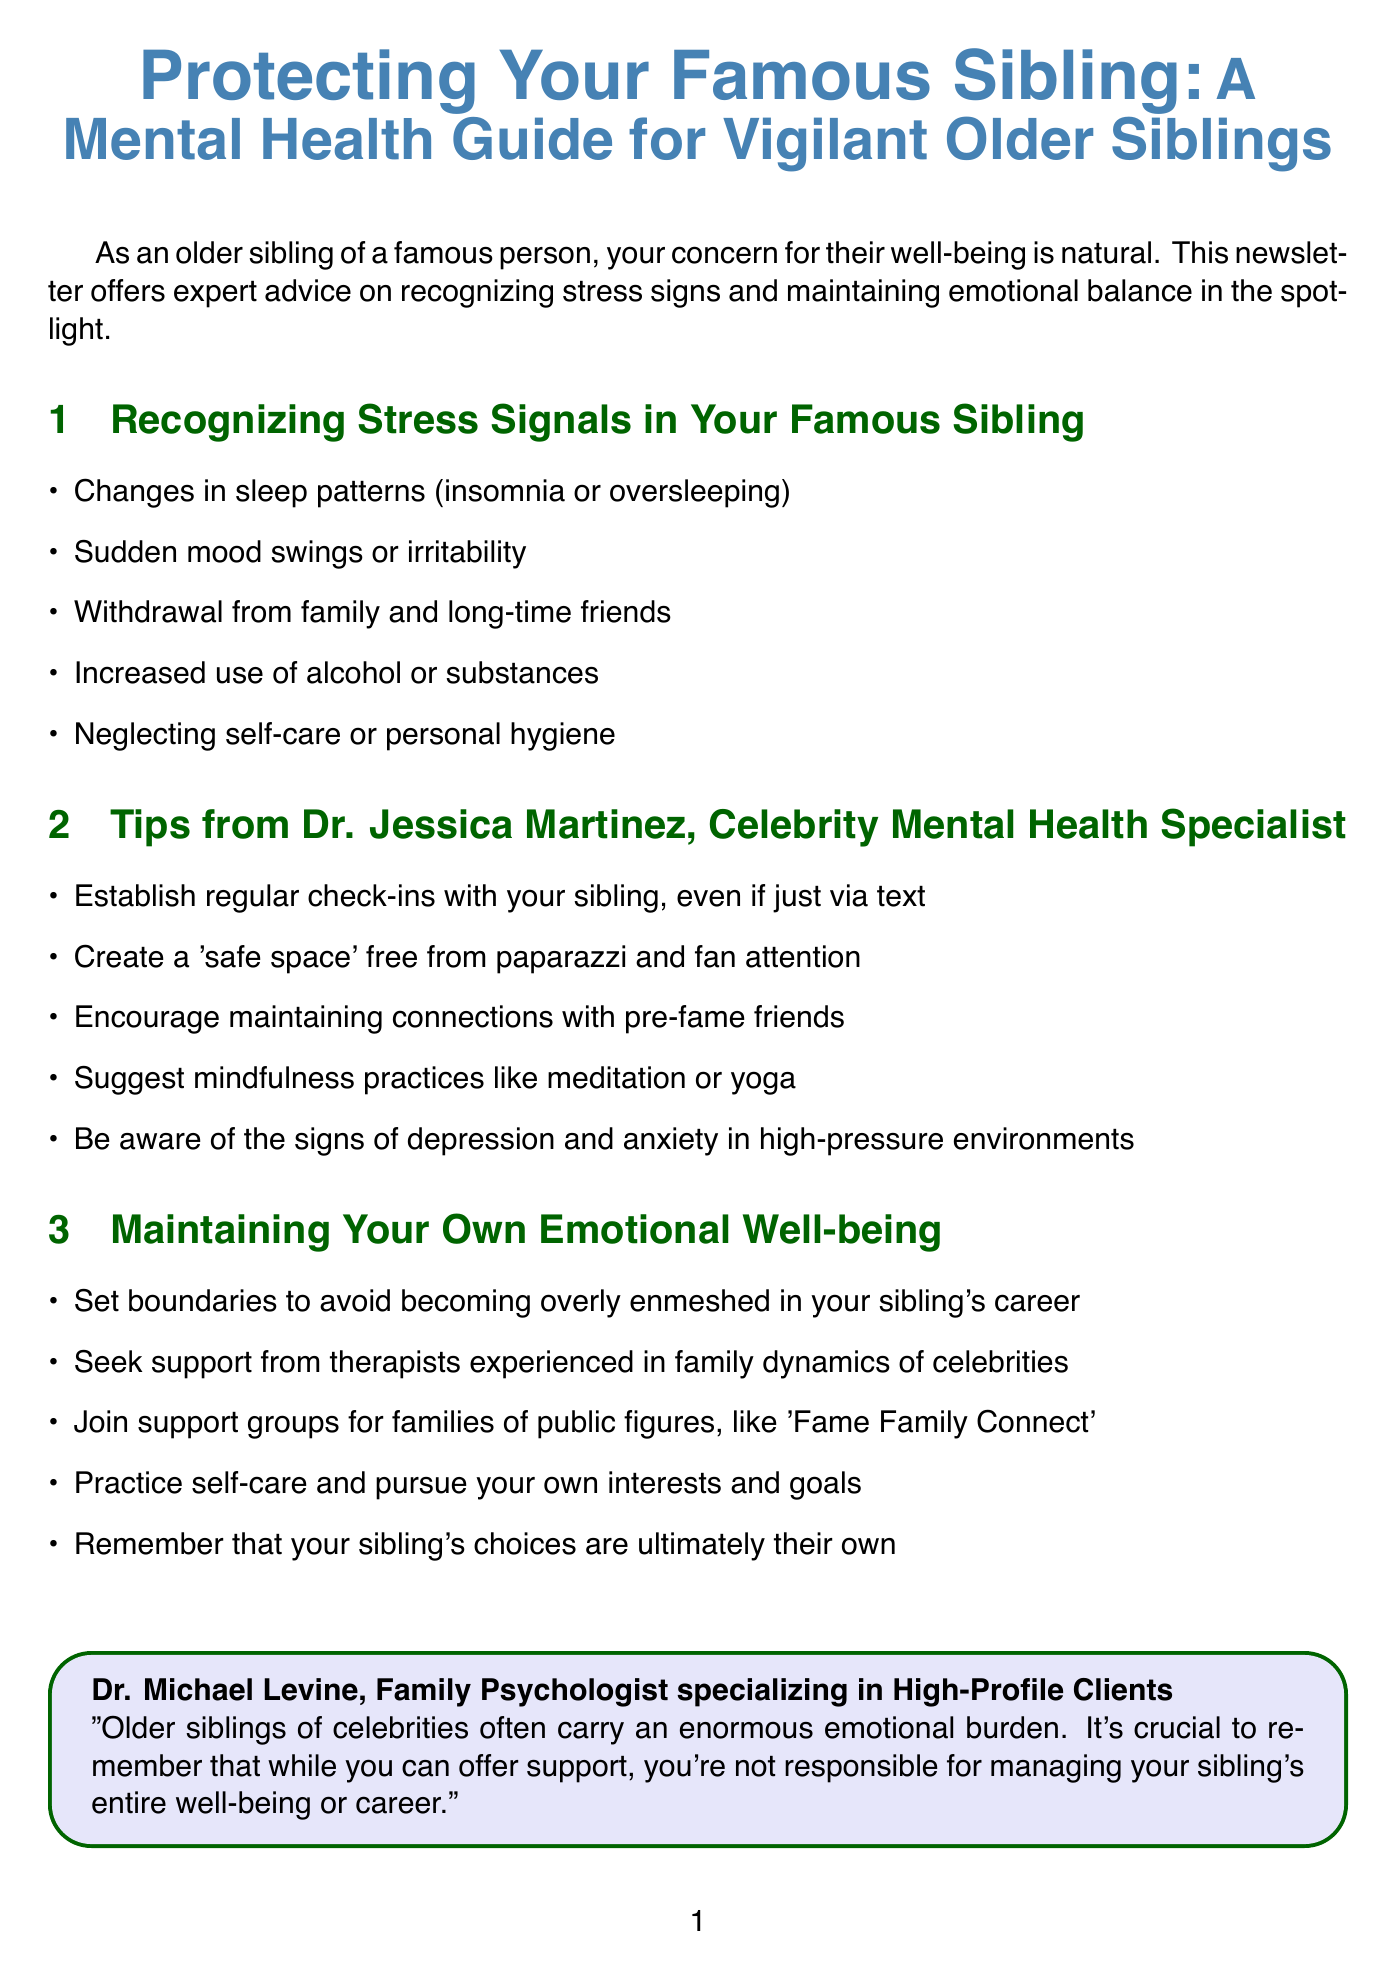What is the title of the newsletter? The title is explicitly listed at the beginning of the document, providing the overall theme of the content.
Answer: Protecting Your Famous Sibling: A Mental Health Guide for Vigilant Older Siblings Who is the author of the expert quote? The document cites Dr. Michael Levine, whose name is included before the quote.
Answer: Dr. Michael Levine What is one sign of stress mentioned? Signs of stress are listed in the first section of the document, detailing specific behaviors to look out for.
Answer: Changes in sleep patterns What is the name of the celebrity case study featured? The document mentions a specific celebrity case study, providing insight into family dynamics and fame.
Answer: The Jonas Brothers How many tips does Dr. Jessica Martinez provide? The number of tips can be counted from the content provided under her section in the newsletter.
Answer: Five What is one recommended resource for families dealing with mental health challenges? The resources are specifically outlined toward the end of the document, offering support options.
Answer: National Alliance on Mental Illness (NAMI) What is a key takeaway for older siblings regarding their emotional well-being? The conclusion stresses a particular aspect that older siblings should keep in mind about their role and emotional health.
Answer: Set boundaries to avoid becoming overly enmeshed in your sibling's career Which psychological practice is suggested for stress relief? The second section details mindfulness techniques as a way to manage stress effectively.
Answer: Meditation or yoga 